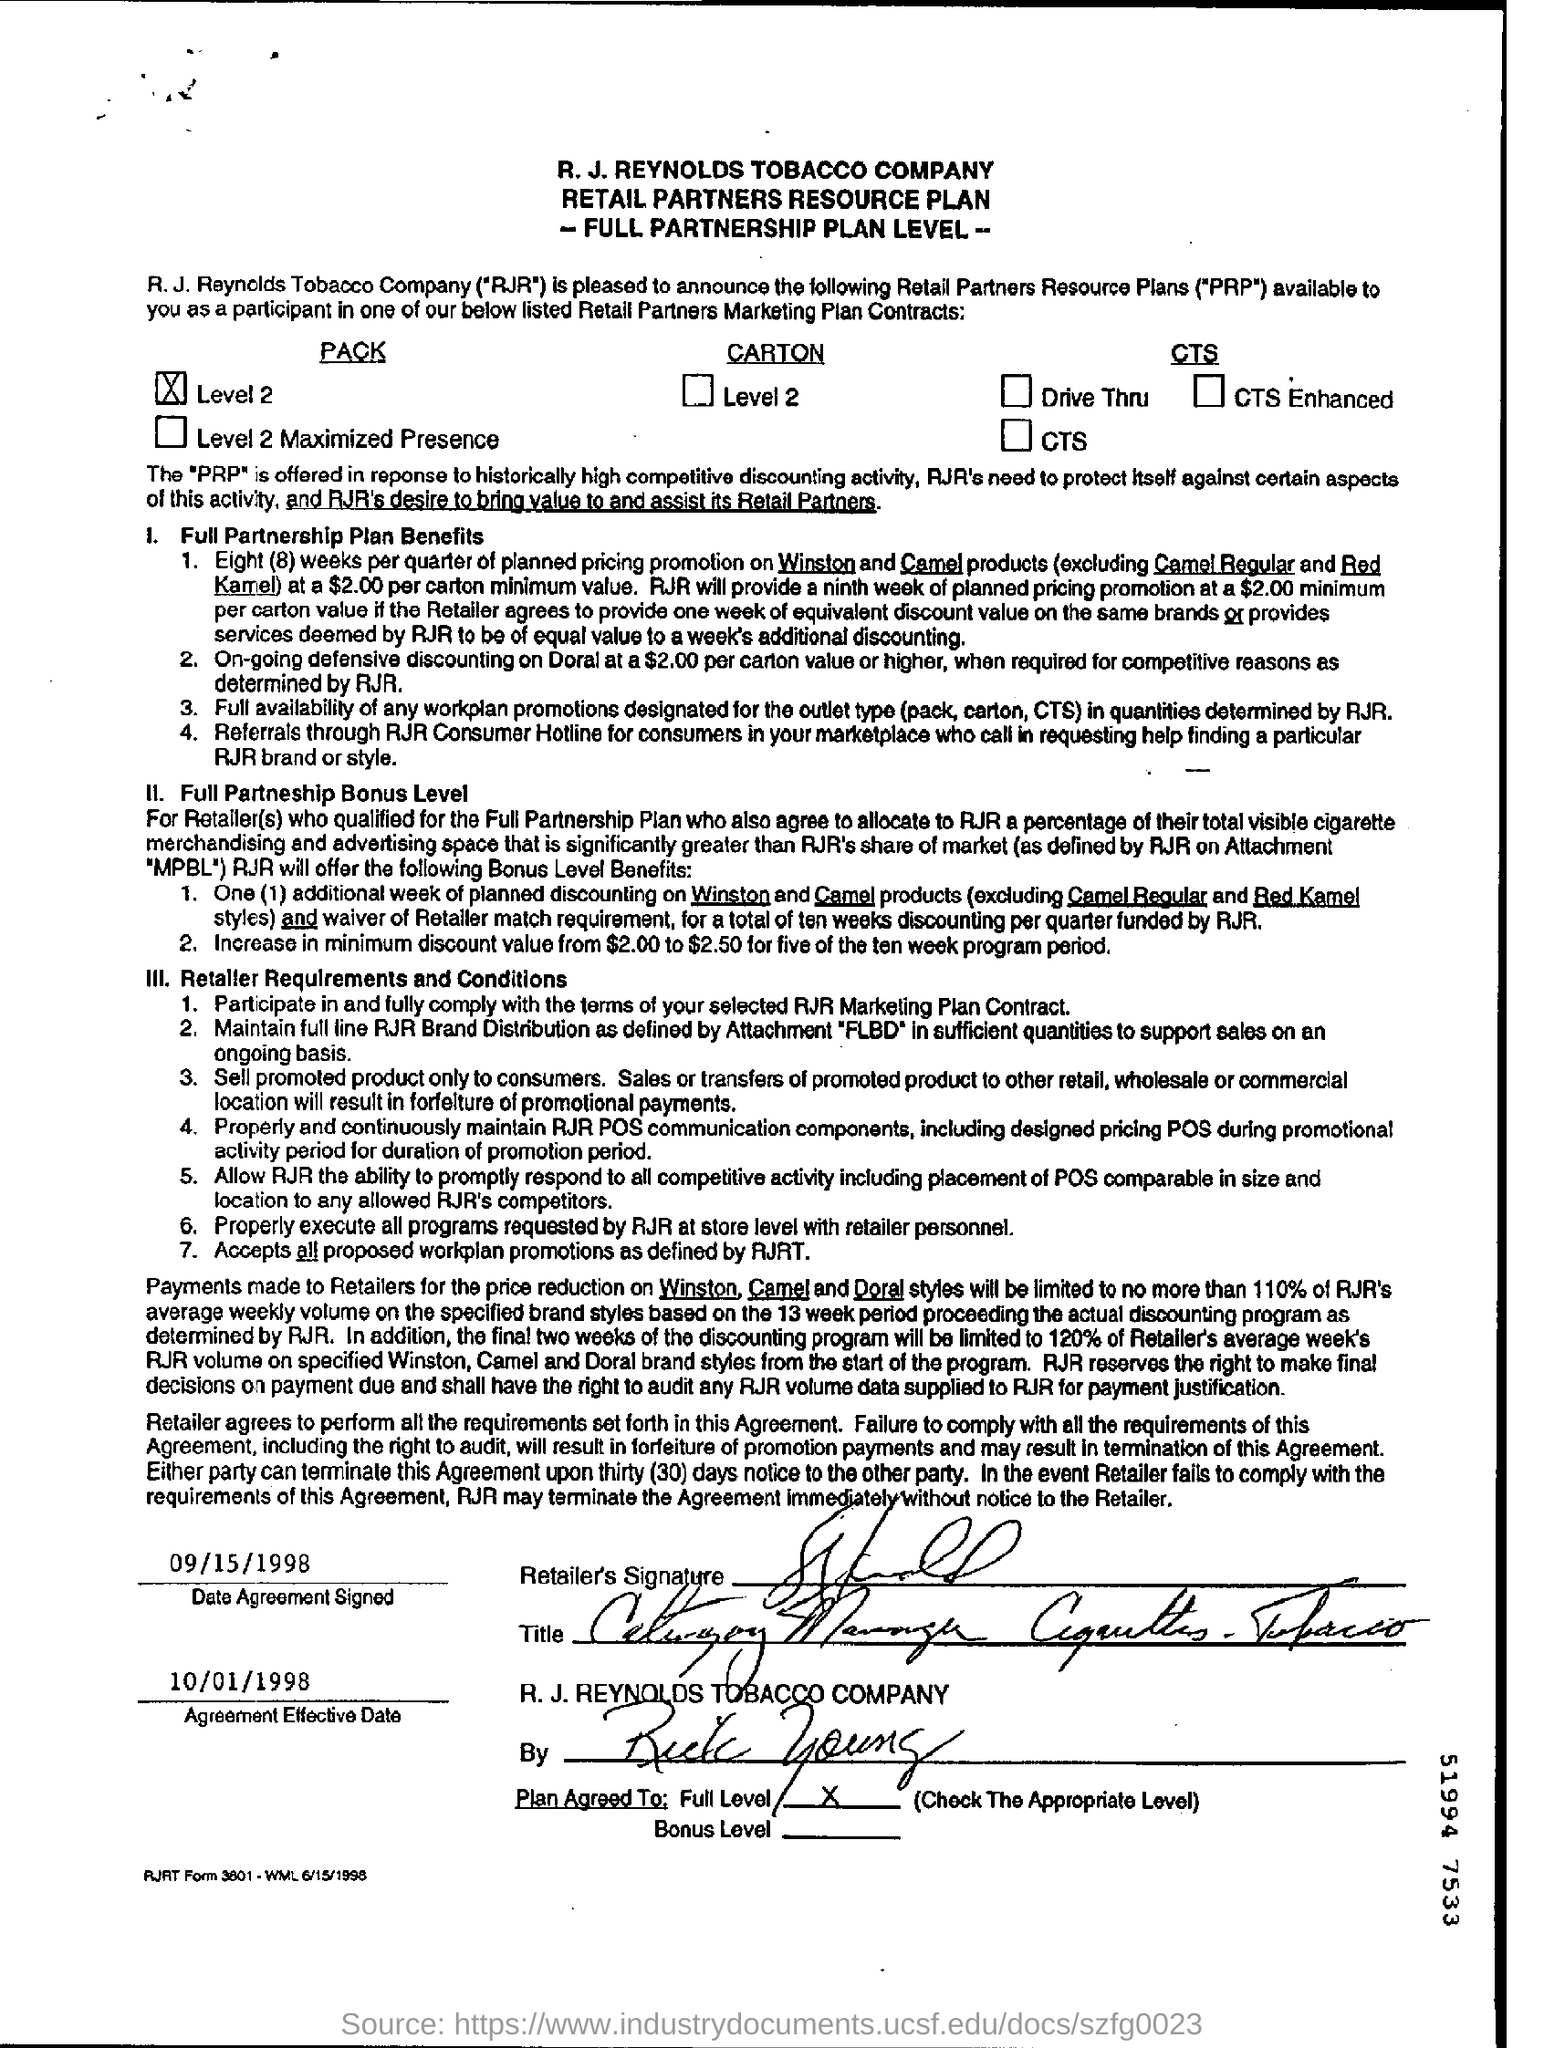Point out several critical features in this image. The effective date of the agreement is October 1, 1998. A contract was signed on September 15, 1998. The R.J. Reynolds Tobacco Company is at the top of the page. 